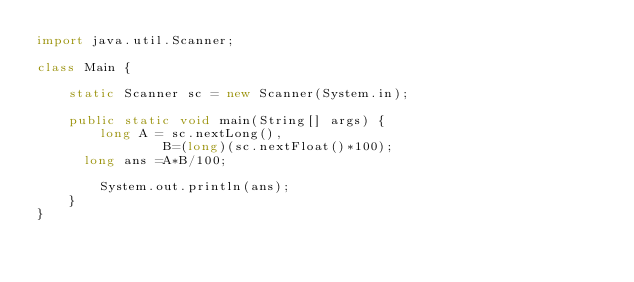<code> <loc_0><loc_0><loc_500><loc_500><_Java_>import java.util.Scanner;

class Main {

	static Scanner sc = new Scanner(System.in);

	public static void main(String[] args) {
		long A = sc.nextLong(),
				B=(long)(sc.nextFloat()*100);
      long ans =A*B/100;
		
		System.out.println(ans);
	}
}</code> 